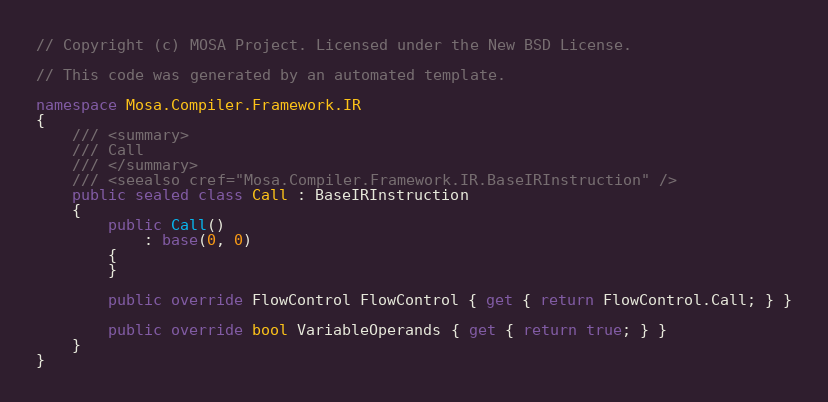<code> <loc_0><loc_0><loc_500><loc_500><_C#_>// Copyright (c) MOSA Project. Licensed under the New BSD License.

// This code was generated by an automated template.

namespace Mosa.Compiler.Framework.IR
{
	/// <summary>
	/// Call
	/// </summary>
	/// <seealso cref="Mosa.Compiler.Framework.IR.BaseIRInstruction" />
	public sealed class Call : BaseIRInstruction
	{
		public Call()
			: base(0, 0)
		{
		}

		public override FlowControl FlowControl { get { return FlowControl.Call; } }

		public override bool VariableOperands { get { return true; } }
	}
}
</code> 